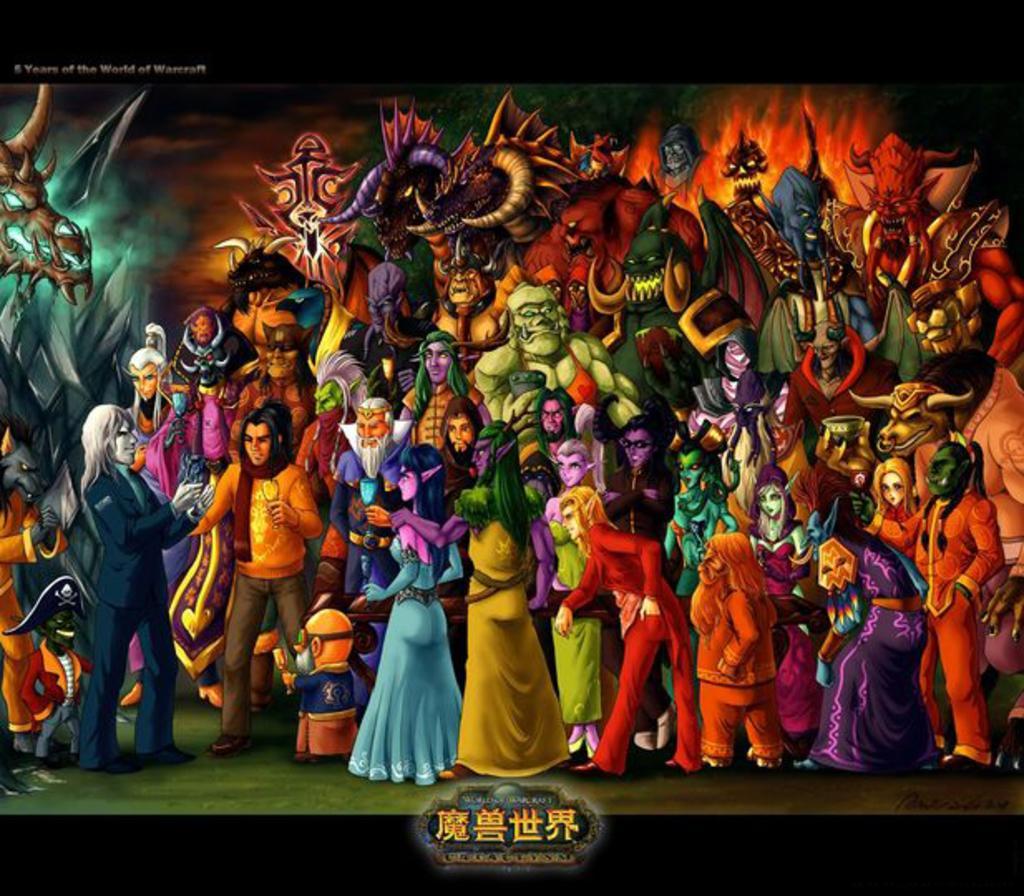In one or two sentences, can you explain what this image depicts? This might be a poster, in this image there are some people who are wearing some costumes and at the bottom of the image there is some text. 